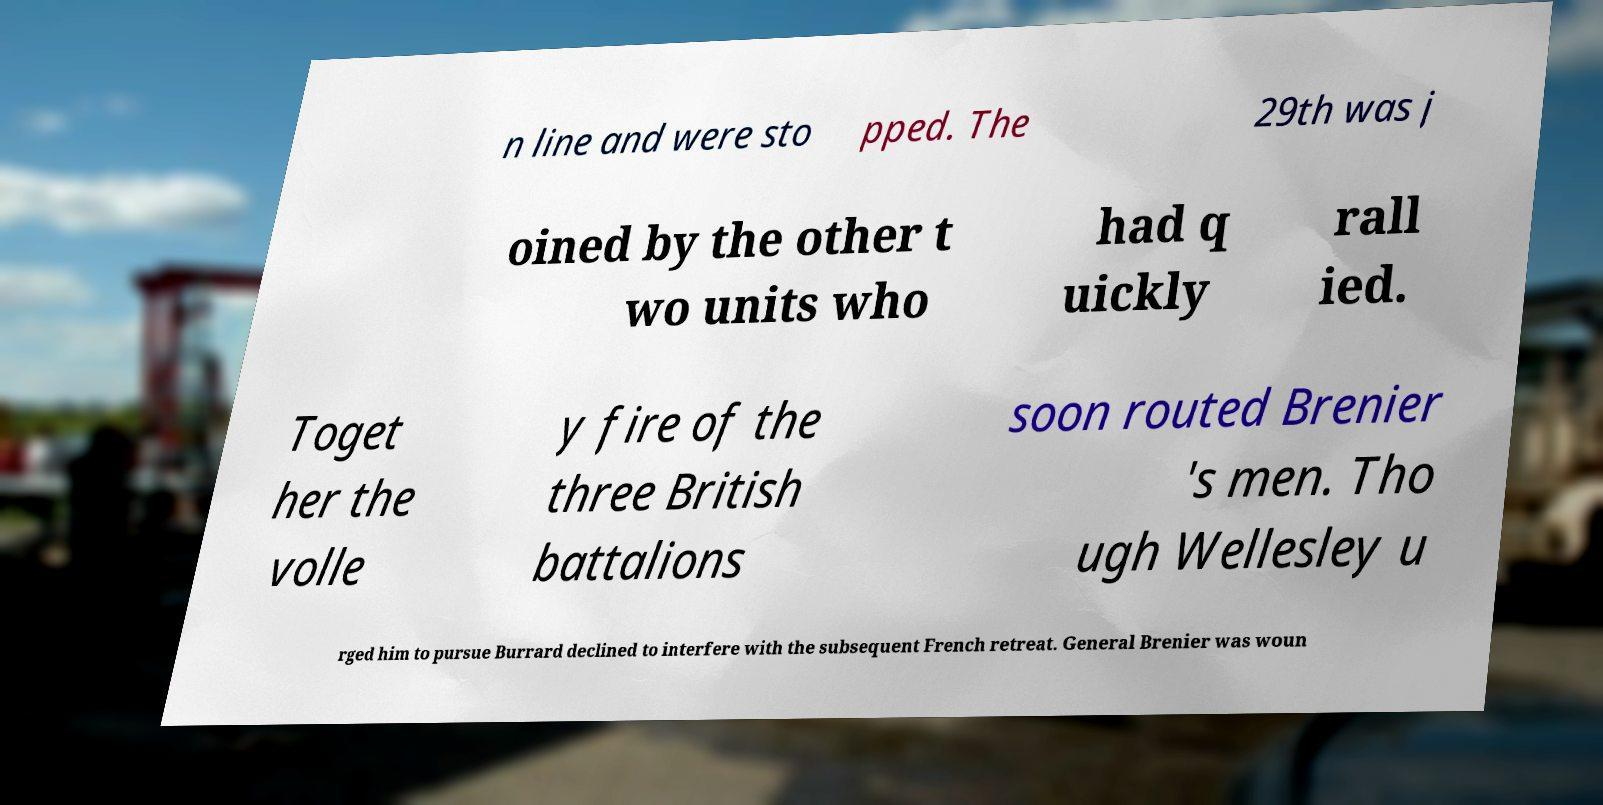For documentation purposes, I need the text within this image transcribed. Could you provide that? n line and were sto pped. The 29th was j oined by the other t wo units who had q uickly rall ied. Toget her the volle y fire of the three British battalions soon routed Brenier 's men. Tho ugh Wellesley u rged him to pursue Burrard declined to interfere with the subsequent French retreat. General Brenier was woun 